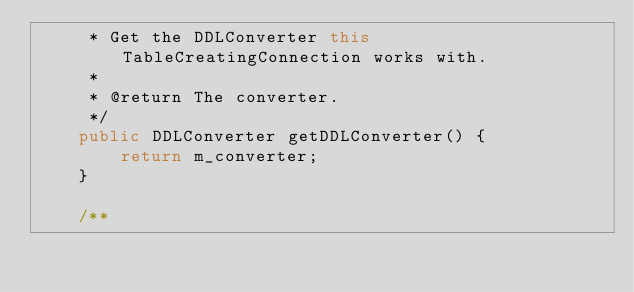Convert code to text. <code><loc_0><loc_0><loc_500><loc_500><_Java_>     * Get the DDLConverter this TableCreatingConnection works with.
     *
     * @return The converter.
     */
    public DDLConverter getDDLConverter() {
        return m_converter;
    }

    /**</code> 